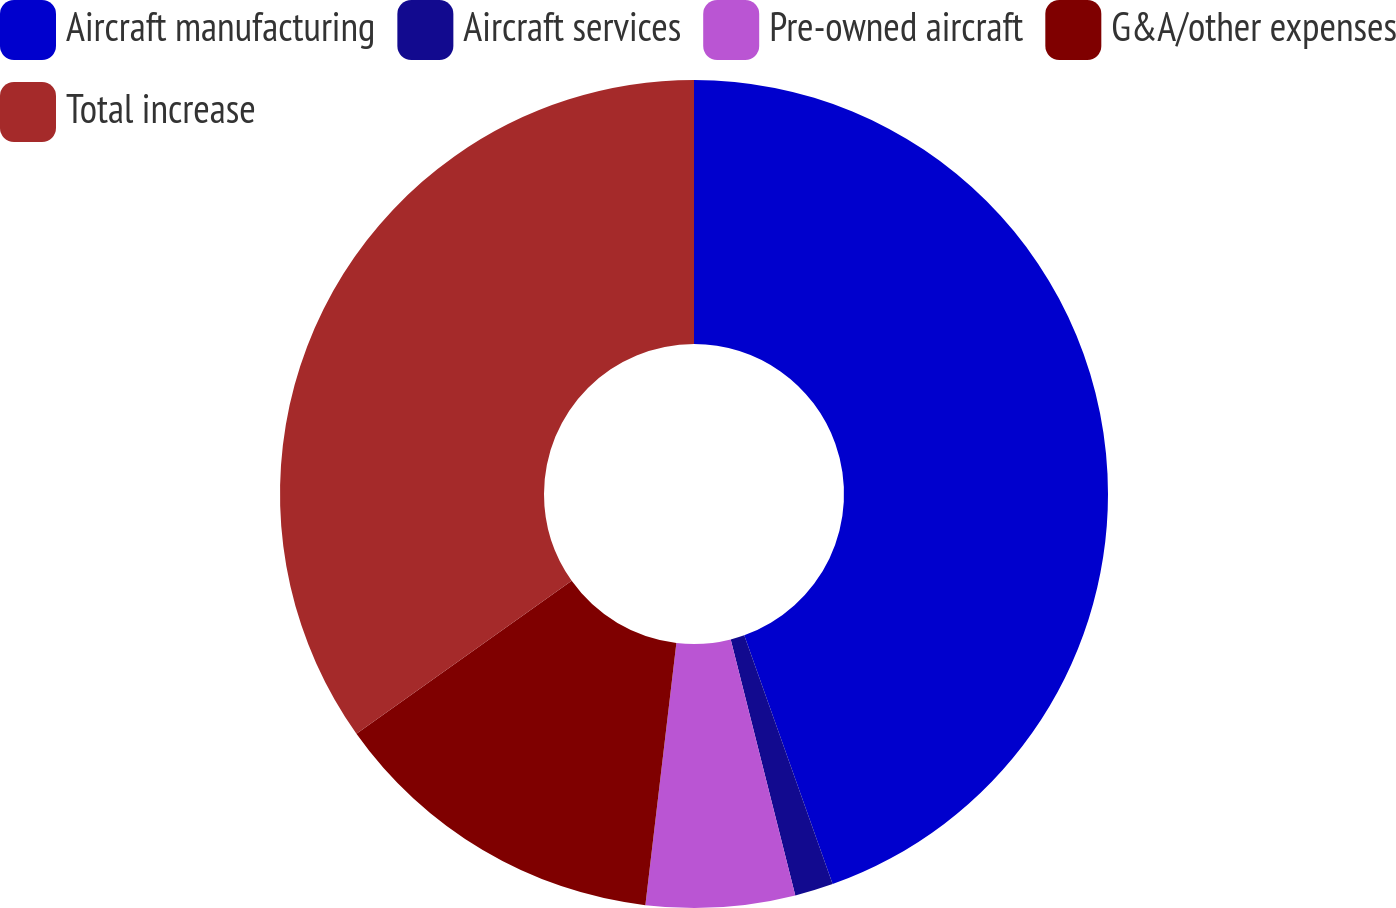<chart> <loc_0><loc_0><loc_500><loc_500><pie_chart><fcel>Aircraft manufacturing<fcel>Aircraft services<fcel>Pre-owned aircraft<fcel>G&A/other expenses<fcel>Total increase<nl><fcel>44.57%<fcel>1.5%<fcel>5.81%<fcel>13.3%<fcel>34.83%<nl></chart> 